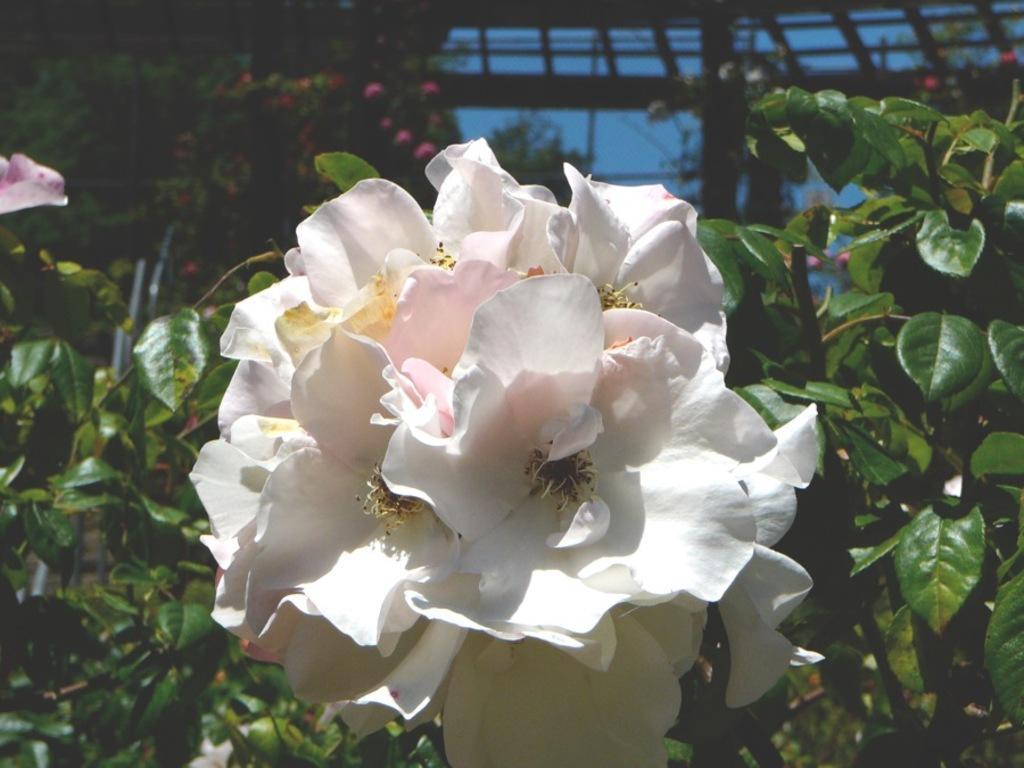Describe this image in one or two sentences. In this picture there are flowers in the center of the image and there is greenery around the area of the image and there is a roof at the top side of the image. 